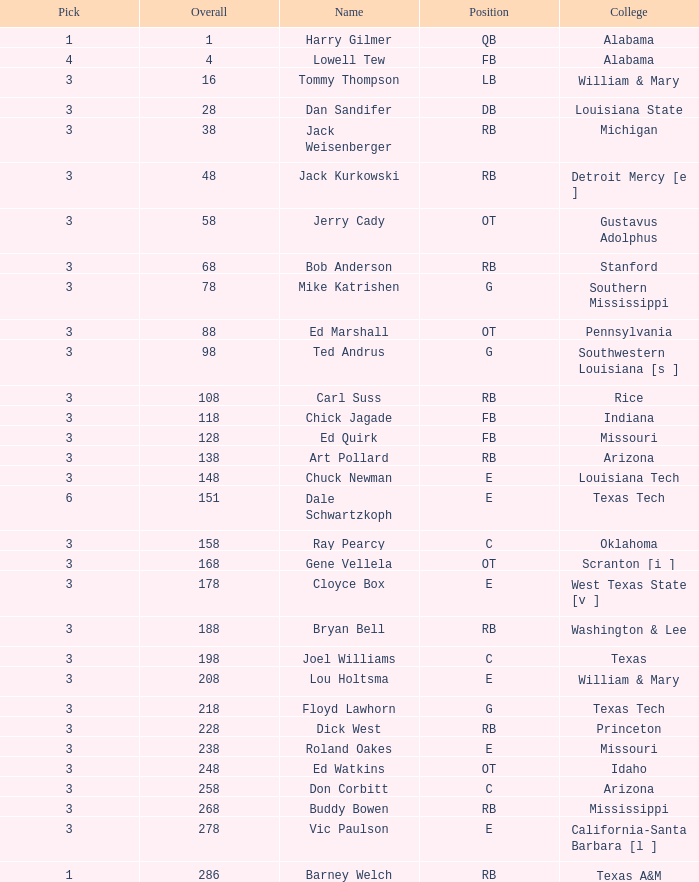What is the overall average for stanford? 68.0. 